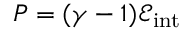Convert formula to latex. <formula><loc_0><loc_0><loc_500><loc_500>P = ( \gamma - 1 ) \mathcal { E } _ { i n t }</formula> 